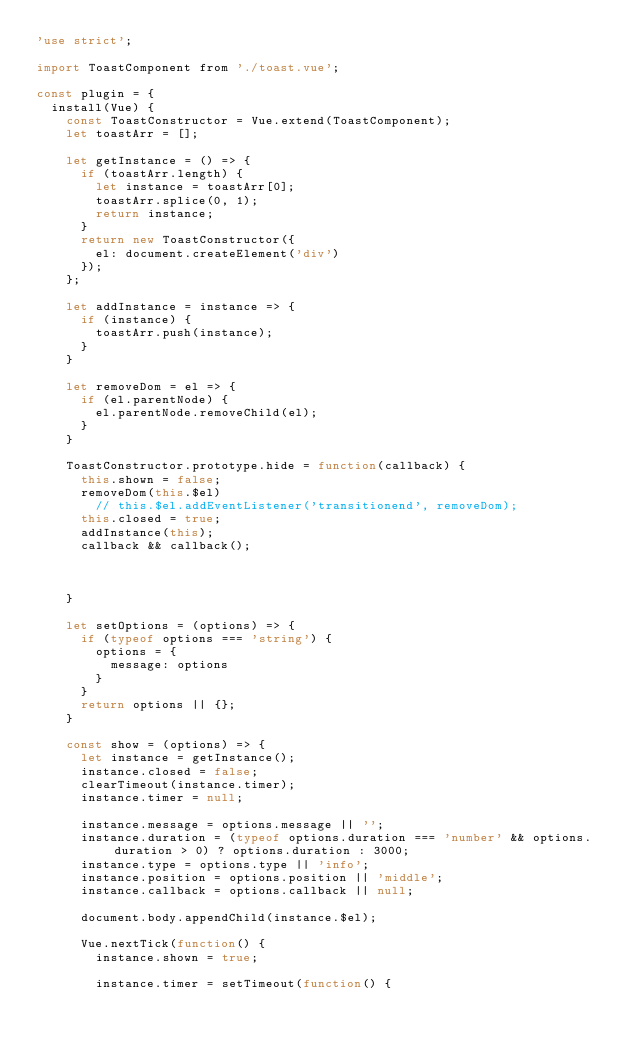Convert code to text. <code><loc_0><loc_0><loc_500><loc_500><_JavaScript_>'use strict';

import ToastComponent from './toast.vue';

const plugin = {
  install(Vue) {
    const ToastConstructor = Vue.extend(ToastComponent);
    let toastArr = [];

    let getInstance = () => {
      if (toastArr.length) {
        let instance = toastArr[0];
        toastArr.splice(0, 1);
        return instance;
      }
      return new ToastConstructor({
        el: document.createElement('div')
      });
    };

    let addInstance = instance => {
      if (instance) {
        toastArr.push(instance);
      }
    }

    let removeDom = el => {
      if (el.parentNode) {
        el.parentNode.removeChild(el);
      }
    }

    ToastConstructor.prototype.hide = function(callback) {
      this.shown = false;
      removeDom(this.$el)
        // this.$el.addEventListener('transitionend', removeDom);
      this.closed = true;
      addInstance(this);
      callback && callback();



    }

    let setOptions = (options) => {
      if (typeof options === 'string') {
        options = {
          message: options
        }
      }
      return options || {};
    }

    const show = (options) => {
      let instance = getInstance();
      instance.closed = false;
      clearTimeout(instance.timer);
      instance.timer = null;

      instance.message = options.message || '';
      instance.duration = (typeof options.duration === 'number' && options.duration > 0) ? options.duration : 3000;
      instance.type = options.type || 'info';
      instance.position = options.position || 'middle';
      instance.callback = options.callback || null;

      document.body.appendChild(instance.$el);

      Vue.nextTick(function() {
        instance.shown = true;

        instance.timer = setTimeout(function() {</code> 